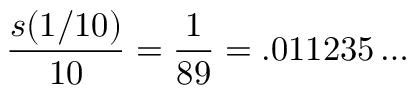<formula> <loc_0><loc_0><loc_500><loc_500>{ \frac { s ( 1 / 1 0 ) } { 1 0 } } = { \frac { 1 } { 8 9 } } = . 0 1 1 2 3 5 \dots</formula> 